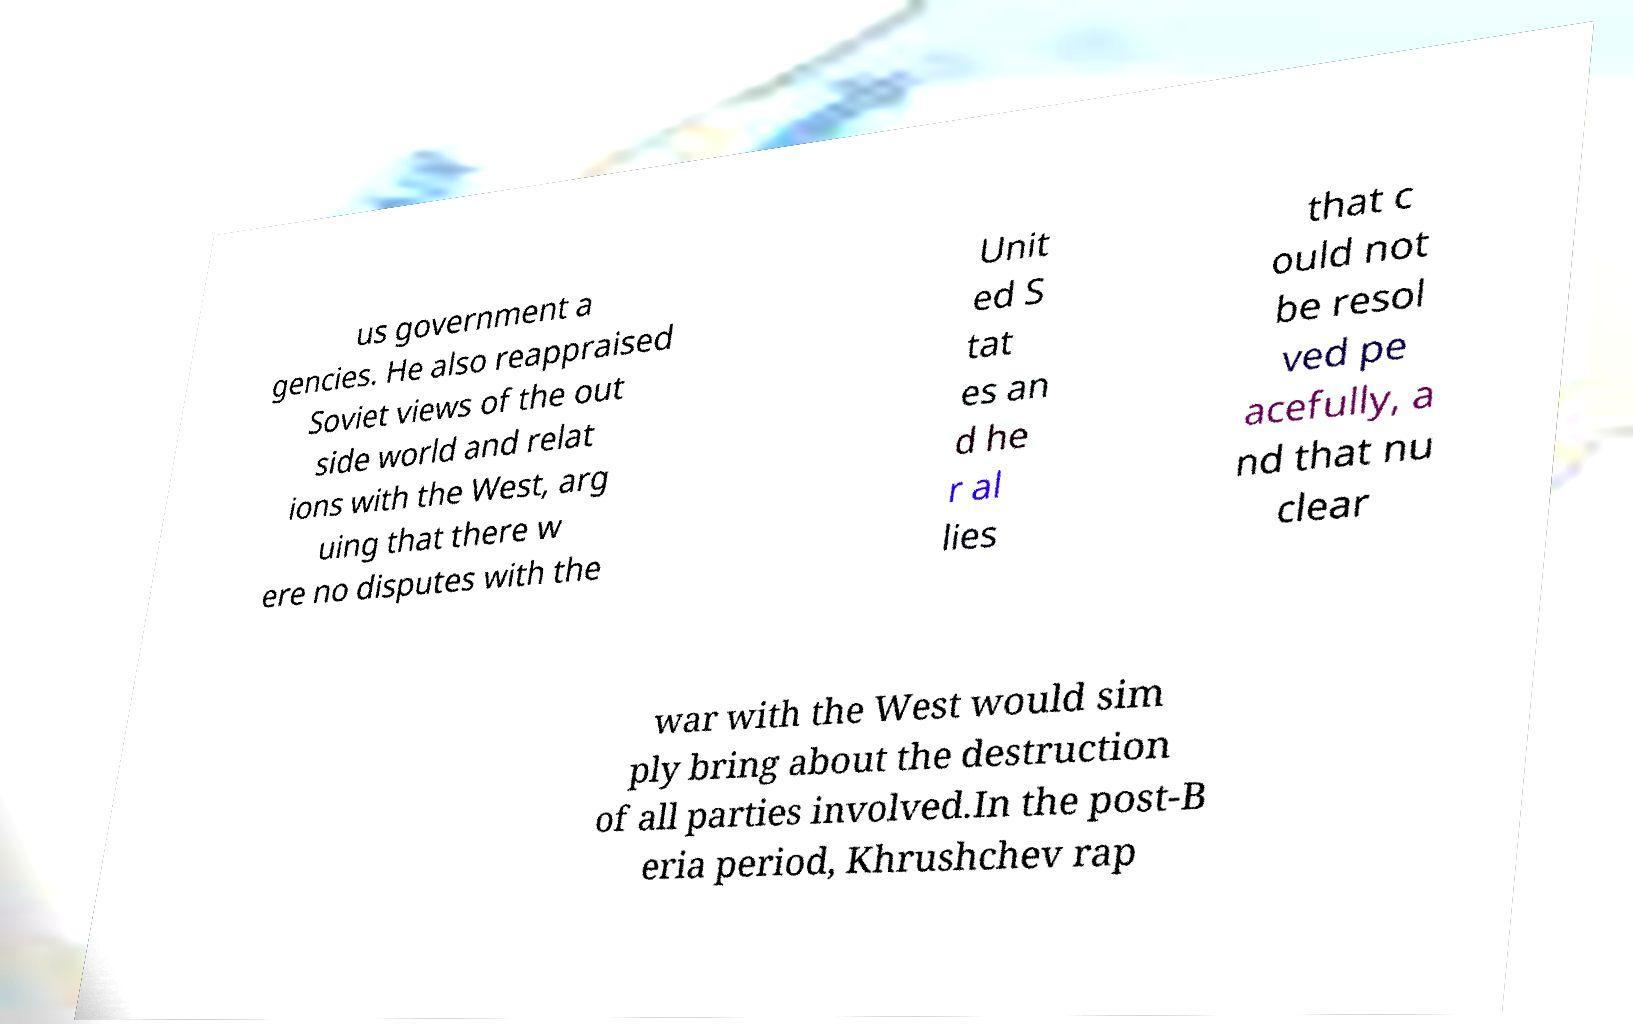Can you read and provide the text displayed in the image?This photo seems to have some interesting text. Can you extract and type it out for me? us government a gencies. He also reappraised Soviet views of the out side world and relat ions with the West, arg uing that there w ere no disputes with the Unit ed S tat es an d he r al lies that c ould not be resol ved pe acefully, a nd that nu clear war with the West would sim ply bring about the destruction of all parties involved.In the post-B eria period, Khrushchev rap 